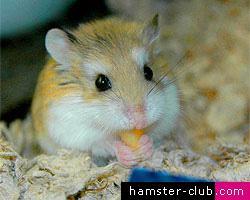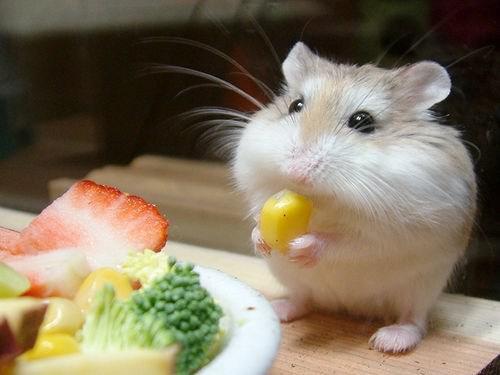The first image is the image on the left, the second image is the image on the right. Considering the images on both sides, is "A bright green broccoli floret is in front of a pet rodent." valid? Answer yes or no. Yes. The first image is the image on the left, the second image is the image on the right. Analyze the images presented: Is the assertion "The rodent in the image on the right has a piece of broccoli in front of it." valid? Answer yes or no. Yes. 